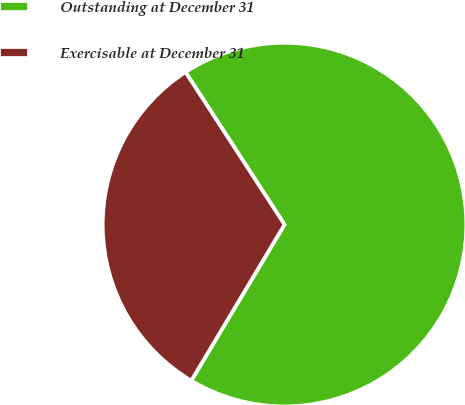<chart> <loc_0><loc_0><loc_500><loc_500><pie_chart><fcel>Outstanding at December 31<fcel>Exercisable at December 31<nl><fcel>67.74%<fcel>32.26%<nl></chart> 